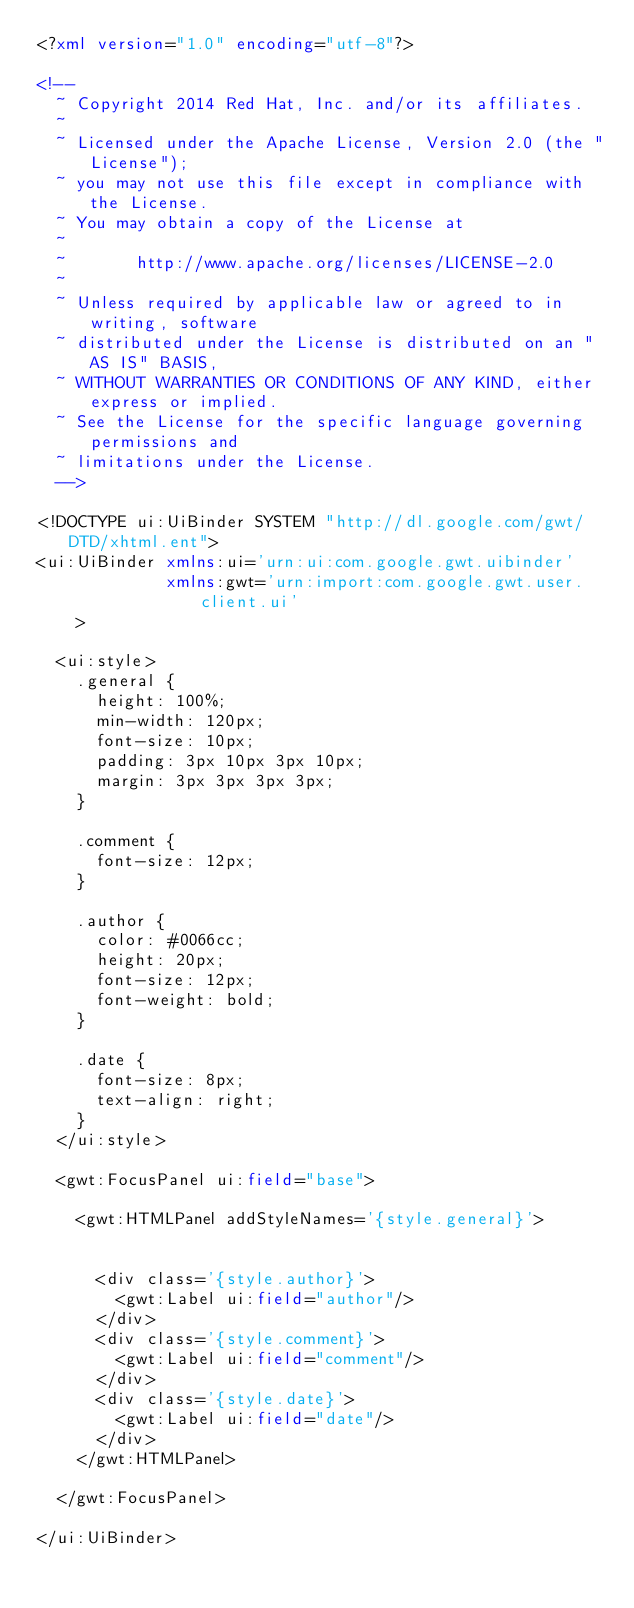Convert code to text. <code><loc_0><loc_0><loc_500><loc_500><_XML_><?xml version="1.0" encoding="utf-8"?>

<!--
  ~ Copyright 2014 Red Hat, Inc. and/or its affiliates.
  ~
  ~ Licensed under the Apache License, Version 2.0 (the "License");
  ~ you may not use this file except in compliance with the License.
  ~ You may obtain a copy of the License at
  ~
  ~       http://www.apache.org/licenses/LICENSE-2.0
  ~
  ~ Unless required by applicable law or agreed to in writing, software
  ~ distributed under the License is distributed on an "AS IS" BASIS,
  ~ WITHOUT WARRANTIES OR CONDITIONS OF ANY KIND, either express or implied.
  ~ See the License for the specific language governing permissions and
  ~ limitations under the License.
  -->

<!DOCTYPE ui:UiBinder SYSTEM "http://dl.google.com/gwt/DTD/xhtml.ent">
<ui:UiBinder xmlns:ui='urn:ui:com.google.gwt.uibinder'
             xmlns:gwt='urn:import:com.google.gwt.user.client.ui'
    >

  <ui:style>
    .general {
      height: 100%;
      min-width: 120px;
      font-size: 10px;
      padding: 3px 10px 3px 10px;
      margin: 3px 3px 3px 3px;
    }

    .comment {
      font-size: 12px;
    }

    .author {
      color: #0066cc;
      height: 20px;
      font-size: 12px;
      font-weight: bold;
    }

    .date {
      font-size: 8px;
      text-align: right;
    }
  </ui:style>

  <gwt:FocusPanel ui:field="base">

    <gwt:HTMLPanel addStyleNames='{style.general}'>


      <div class='{style.author}'>
        <gwt:Label ui:field="author"/>
      </div>
      <div class='{style.comment}'>
        <gwt:Label ui:field="comment"/>
      </div>
      <div class='{style.date}'>
        <gwt:Label ui:field="date"/>
      </div>
    </gwt:HTMLPanel>

  </gwt:FocusPanel>

</ui:UiBinder>
</code> 